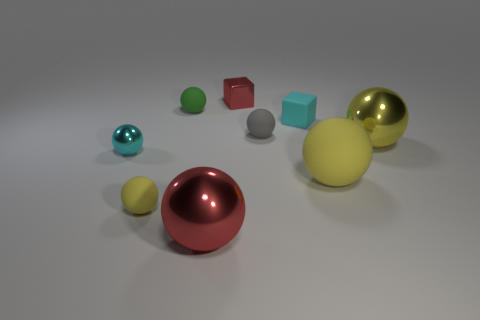Subtract all cyan spheres. How many spheres are left? 6 Add 1 large red metallic spheres. How many objects exist? 10 Subtract all gray blocks. How many yellow balls are left? 3 Add 3 tiny green spheres. How many tiny green spheres exist? 4 Subtract all cyan spheres. How many spheres are left? 6 Subtract 0 brown blocks. How many objects are left? 9 Subtract all blocks. How many objects are left? 7 Subtract 2 balls. How many balls are left? 5 Subtract all gray balls. Subtract all red cubes. How many balls are left? 6 Subtract all tiny green matte things. Subtract all small green balls. How many objects are left? 7 